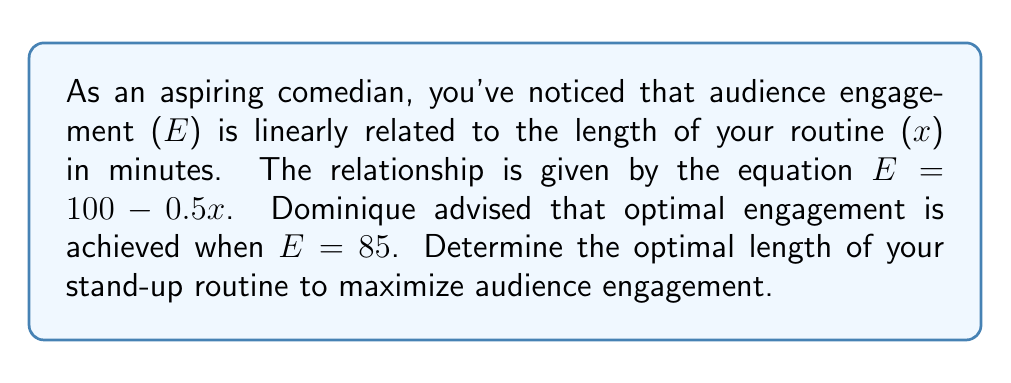What is the answer to this math problem? 1) We start with the given linear equation:
   $E = 100 - 0.5x$

2) We're told that optimal engagement is achieved when E = 85. Let's substitute this:
   $85 = 100 - 0.5x$

3) Now, we solve for x:
   $85 - 100 = -0.5x$
   $-15 = -0.5x$

4) Divide both sides by -0.5:
   $\frac{-15}{-0.5} = x$
   $30 = x$

5) Therefore, the optimal length of the routine is 30 minutes.

6) We can verify:
   $E = 100 - 0.5(30) = 100 - 15 = 85$

This confirms that a 30-minute routine achieves the optimal engagement of 85.
Answer: 30 minutes 